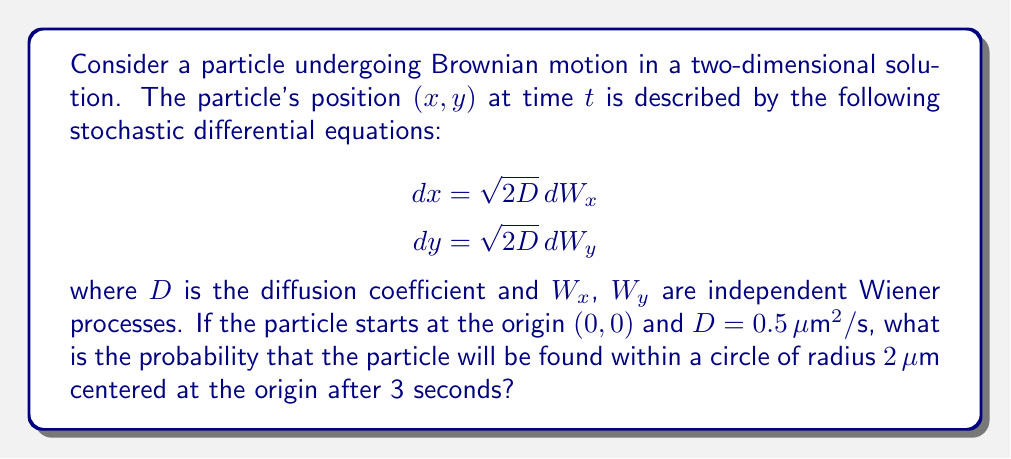Solve this math problem. Let's approach this step-by-step:

1) In Brownian motion, the displacement in each dimension follows a normal distribution with mean 0 and variance $2Dt$, where $t$ is the time elapsed.

2) After 3 seconds, the variance in each dimension is:
   $$\sigma^2 = 2Dt = 2 \cdot 0.5 \cdot 3 = 3 \mu m^2$$

3) The standard deviation is therefore:
   $$\sigma = \sqrt{3} \mu m$$

4) In two dimensions, the total displacement $r$ from the origin follows a Rayleigh distribution with parameter $\sigma$. The cumulative distribution function (CDF) of the Rayleigh distribution is:

   $$F(r) = 1 - e^{-r^2/(2\sigma^2)}$$

5) We want to find the probability that $r \leq 2 \mu m$ after 3 seconds. This is equivalent to evaluating the CDF at $r = 2 \mu m$:

   $$P(r \leq 2) = 1 - e^{-2^2/(2 \cdot 3)} = 1 - e^{-2/3}$$

6) Calculating this value:
   $$1 - e^{-2/3} \approx 0.4866$$

Therefore, the probability of finding the particle within a circle of radius $2 \mu m$ after 3 seconds is approximately 0.4866 or 48.66%.
Answer: 0.4866 